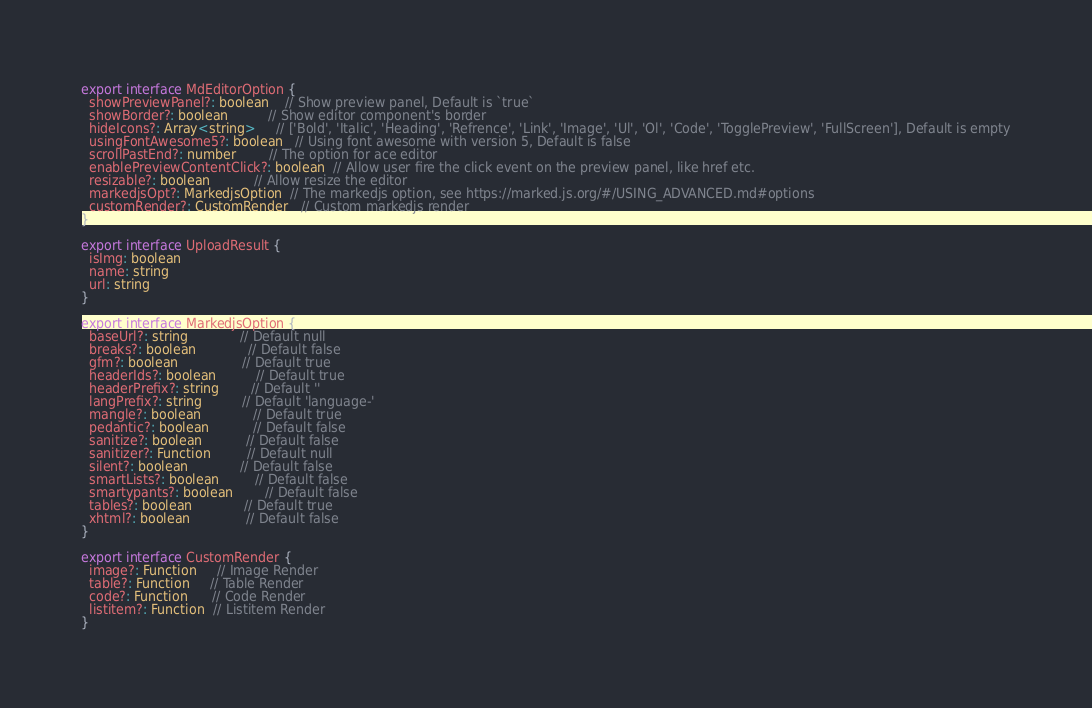Convert code to text. <code><loc_0><loc_0><loc_500><loc_500><_TypeScript_>export interface MdEditorOption {
  showPreviewPanel?: boolean    // Show preview panel, Default is `true`
  showBorder?: boolean          // Show editor component's border
  hideIcons?: Array<string>     // ['Bold', 'Italic', 'Heading', 'Refrence', 'Link', 'Image', 'Ul', 'Ol', 'Code', 'TogglePreview', 'FullScreen'], Default is empty
  usingFontAwesome5?: boolean   // Using font awesome with version 5, Default is false
  scrollPastEnd?: number        // The option for ace editor
  enablePreviewContentClick?: boolean  // Allow user fire the click event on the preview panel, like href etc.
  resizable?: boolean           // Allow resize the editor
  markedjsOpt?: MarkedjsOption  // The markedjs option, see https://marked.js.org/#/USING_ADVANCED.md#options
  customRender?: CustomRender   // Custom markedjs render
}

export interface UploadResult {
  isImg: boolean
  name: string
  url: string
}

export interface MarkedjsOption {
  baseUrl?: string             // Default null
  breaks?: boolean             // Default false
  gfm?: boolean                // Default true
  headerIds?: boolean          // Default true
  headerPrefix?: string        // Default ''
  langPrefix?: string          // Default 'language-'
  mangle?: boolean             // Default true
  pedantic?: boolean           // Default false
  sanitize?: boolean           // Default false
  sanitizer?: Function         // Default null
  silent?: boolean             // Default false
  smartLists?: boolean         // Default false
  smartypants?: boolean        // Default false
  tables?: boolean             // Default true
  xhtml?: boolean              // Default false
}

export interface CustomRender {
  image?: Function     // Image Render
  table?: Function     // Table Render
  code?: Function      // Code Render
  listitem?: Function  // Listitem Render
}
</code> 